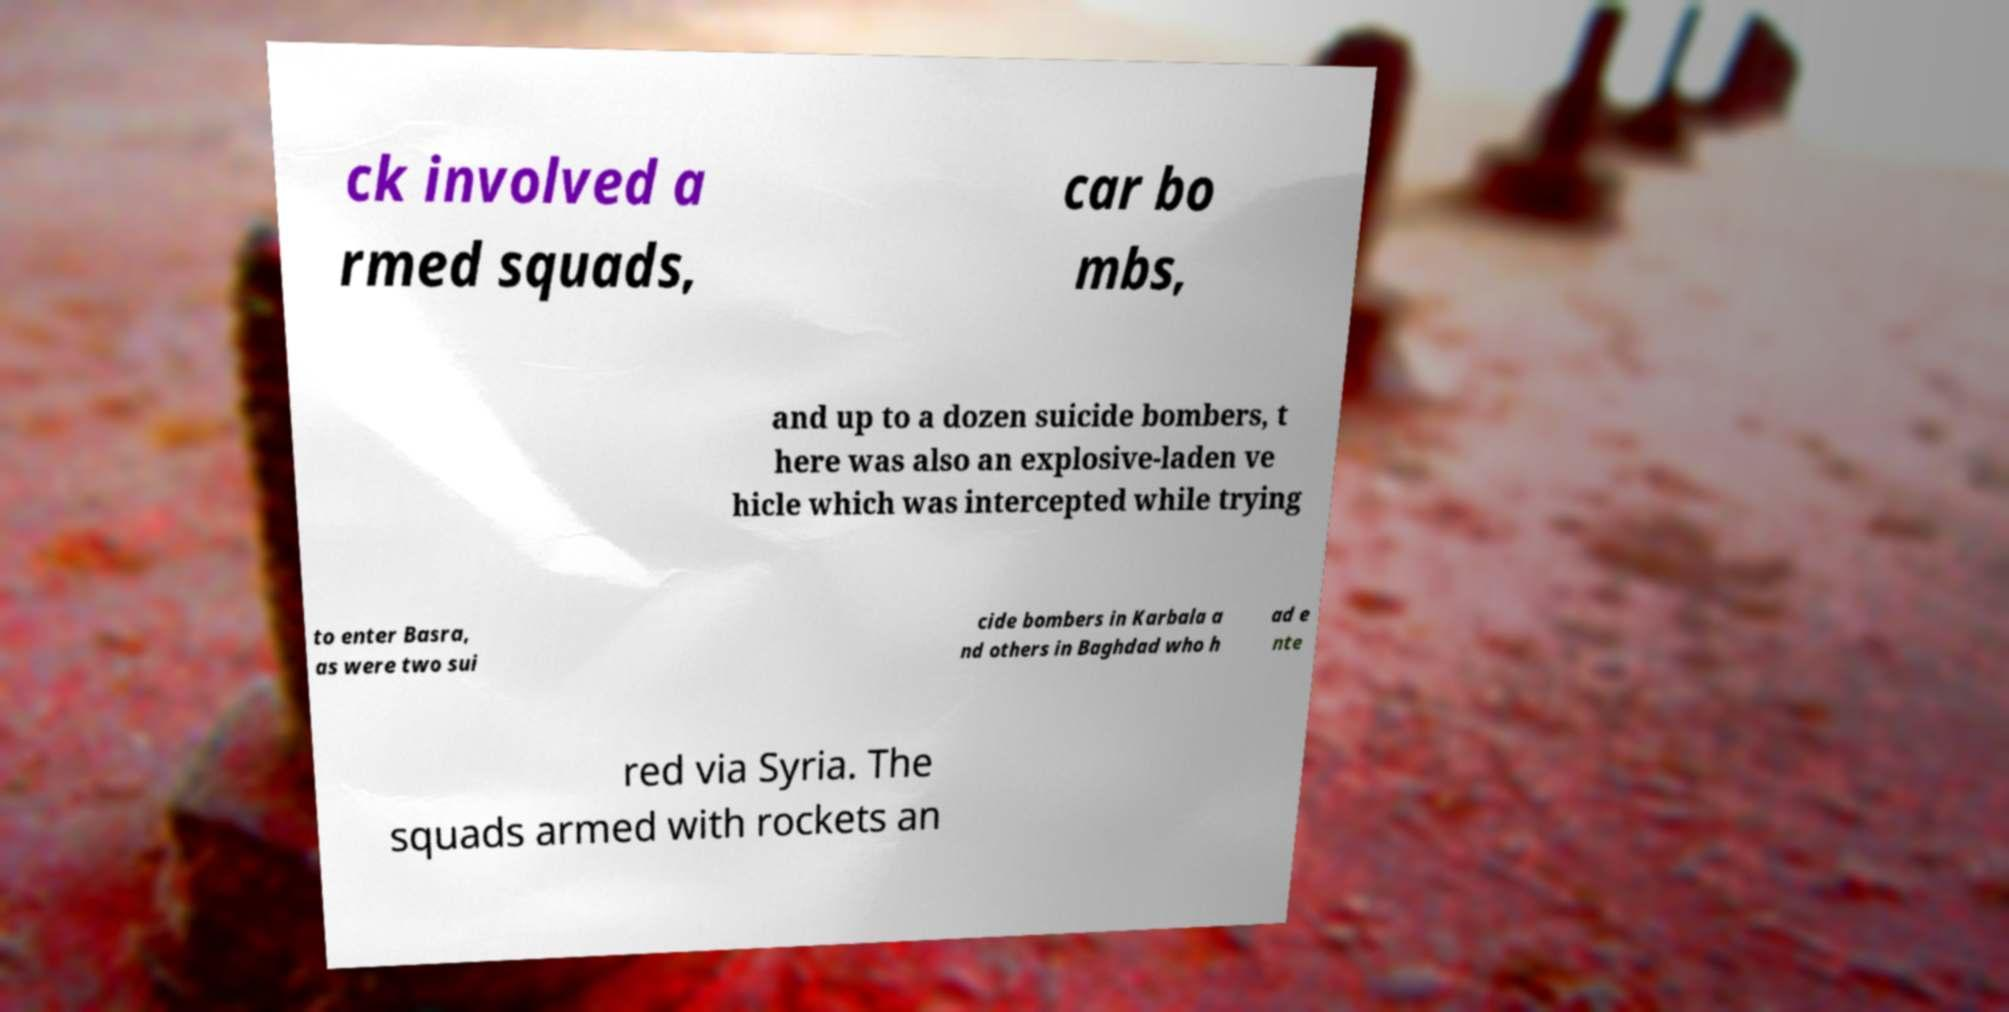Please read and relay the text visible in this image. What does it say? ck involved a rmed squads, car bo mbs, and up to a dozen suicide bombers, t here was also an explosive-laden ve hicle which was intercepted while trying to enter Basra, as were two sui cide bombers in Karbala a nd others in Baghdad who h ad e nte red via Syria. The squads armed with rockets an 